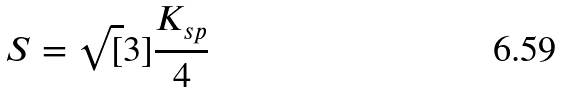Convert formula to latex. <formula><loc_0><loc_0><loc_500><loc_500>S = \sqrt { [ } 3 ] { \frac { K _ { s p } } { 4 } }</formula> 